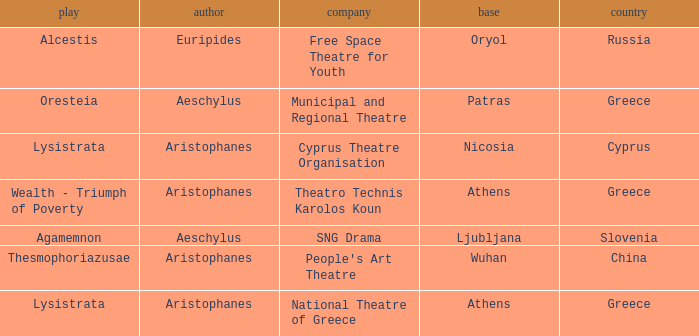What is the corporation when the basis is ljubljana? SNG Drama. 